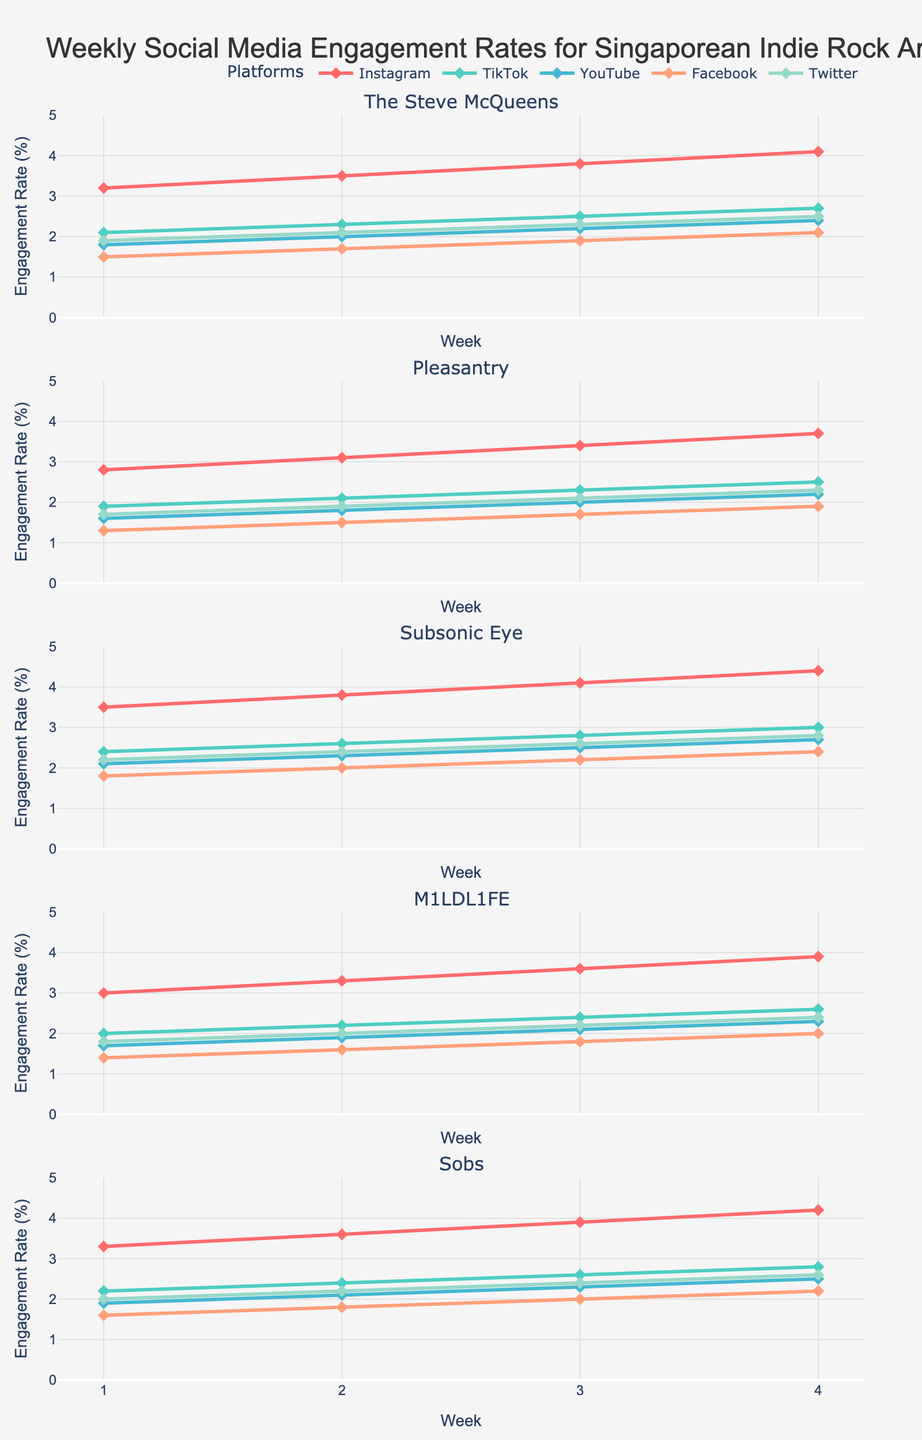Which artist showed the highest engagement rate on Instagram by Week 4? To answer this, look at the engagement rates on Instagram for all artists in Week 4. The Steve McQueens has a rate of 4.1%, Pleasantry 3.7%, Subsonic Eye 4.4%, M1LDL1FE 3.9%, and Sobs 4.2%. Among these, Subsonic Eye has the highest rate.
Answer: Subsonic Eye How did the engagement rate on TikTok for The Steve McQueens change from Week 1 to Week 4? Identify the TikTok engagement rates for The Steve McQueens across the four weeks: Week 1 is 2.1%, Week 2 is 2.3%, Week 3 is 2.5%, and Week 4 is 2.7%. The engagement rate increased steadily each week.
Answer: Increased Among the five platforms, which one had the lowest engagement rate across all artists in Week 1? Check the Week 1 engagement rates for all artists on all five platforms. Instagram, TikTok, YouTube, Facebook, and Twitter ranges respectively: 2.8-3.5%, 1.9-2.4%, 1.6-2.1%, 1.3-1.8%, and 1.7-2.2%. Facebook has the lowest range of 1.3-1.8%.
Answer: Facebook Compare the growth rates on YouTube for Pleasantry and Sobs from Week 1 to Week 4. Which artist had a greater increase? Calculate the increase in YouTube engagement for Pleasantry (Week 1: 1.6%, Week 4: 2.2%) and Sobs (Week 1: 1.9%, Week 4: 2.5%). Pleasantry increased by 0.6% (2.2% - 1.6%) and Sobs by 0.6% (2.5% - 1.9%). Both had the same increase.
Answer: Equal Which platform showed the highest overall engagement for M1LDL1FE across the four weeks? Check the engagement rates of M1LDL1FE across all platforms for each week and sum them up. Instagram has summations of (3.0+3.3+3.6+3.9=13.8%), TikTok (2.0+2.2+2.4+2.6=9.2%), YouTube (1.7+1.9+2.1+2.3=8.0%), Facebook (1.4+1.6+1.8+2.0=6.8%), and Twitter (1.8+2.0+2.2+2.4=8.4%). Instagram has the highest overall engagement.
Answer: Instagram By Week 3, which artist had the lowest engagement rate on Twitter, and what was it? Check the engagement rates on Twitter for Week 3. The values are as follows: The Steve McQueens (2.3%), Pleasantry (2.1%), Subsonic Eye (2.6%), M1LDL1FE (2.2%), and Sobs (2.4%). The lowest rate is 2.1% for Pleasantry.
Answer: Pleasantry What is the combined engagement rate on Facebook for all artists in Week 2? Sum the Facebook engagement rates for all artists in Week 2: The Steve McQueens (1.7%), Pleasantry (1.5%), Subsonic Eye (2.0%), M1LDL1FE (1.6%), and Sobs (1.8%). Total = 1.7% + 1.5% + 2.0% + 1.6% + 1.8% = 8.6%.
Answer: 8.6% Which artist had the most consistent engagement rate on TikTok across the four weeks, i.e., the least variation? Calculate the variation in TikTok engagement rates across four weeks for each artist. The Steve McQueens: 2.1-2.7%, Pleasantry: 1.9-2.5%, Subsonic Eye: 2.4-3.0%, M1LDL1FE: 2.0-2.6%, Sobs: 2.2-2.8%. The Steve McQueens had the smallest range (0.6).
Answer: The Steve McQueens 